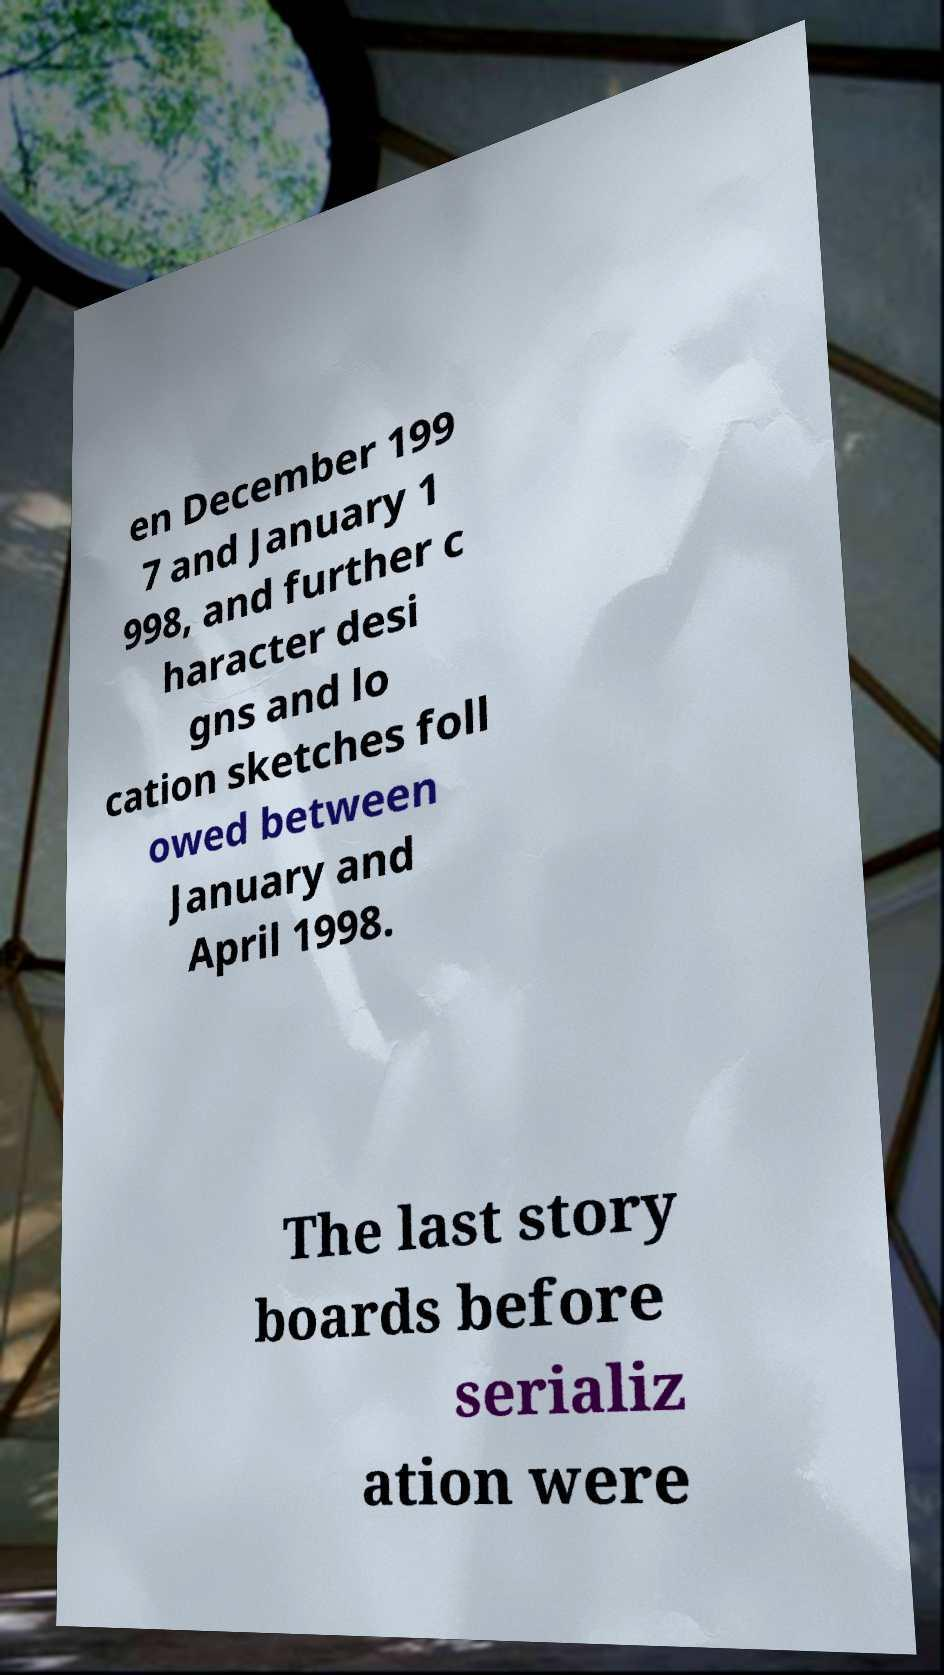There's text embedded in this image that I need extracted. Can you transcribe it verbatim? en December 199 7 and January 1 998, and further c haracter desi gns and lo cation sketches foll owed between January and April 1998. The last story boards before serializ ation were 